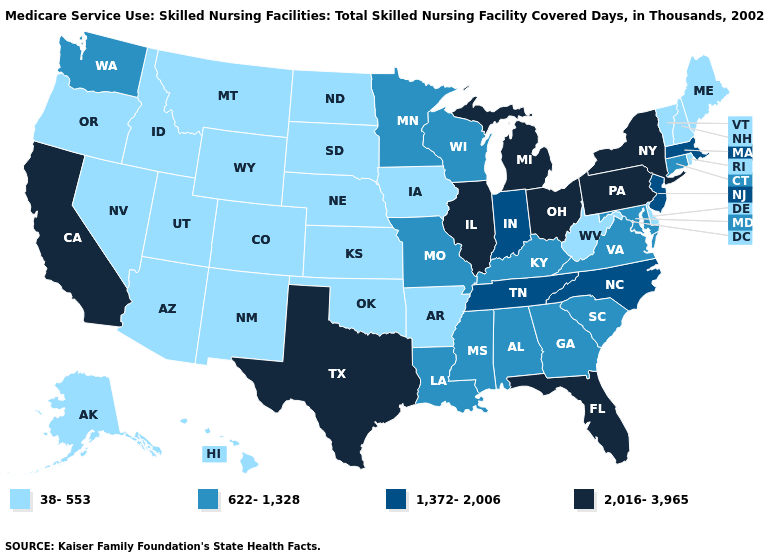Does Arizona have the highest value in the West?
Short answer required. No. How many symbols are there in the legend?
Keep it brief. 4. What is the highest value in the USA?
Answer briefly. 2,016-3,965. Does California have the lowest value in the USA?
Keep it brief. No. What is the value of Iowa?
Give a very brief answer. 38-553. Does the first symbol in the legend represent the smallest category?
Short answer required. Yes. Does Ohio have a lower value than Vermont?
Concise answer only. No. Is the legend a continuous bar?
Answer briefly. No. Name the states that have a value in the range 1,372-2,006?
Quick response, please. Indiana, Massachusetts, New Jersey, North Carolina, Tennessee. Is the legend a continuous bar?
Keep it brief. No. Does Oklahoma have the lowest value in the USA?
Write a very short answer. Yes. Is the legend a continuous bar?
Answer briefly. No. Name the states that have a value in the range 38-553?
Write a very short answer. Alaska, Arizona, Arkansas, Colorado, Delaware, Hawaii, Idaho, Iowa, Kansas, Maine, Montana, Nebraska, Nevada, New Hampshire, New Mexico, North Dakota, Oklahoma, Oregon, Rhode Island, South Dakota, Utah, Vermont, West Virginia, Wyoming. What is the value of Alaska?
Write a very short answer. 38-553. Name the states that have a value in the range 2,016-3,965?
Write a very short answer. California, Florida, Illinois, Michigan, New York, Ohio, Pennsylvania, Texas. 